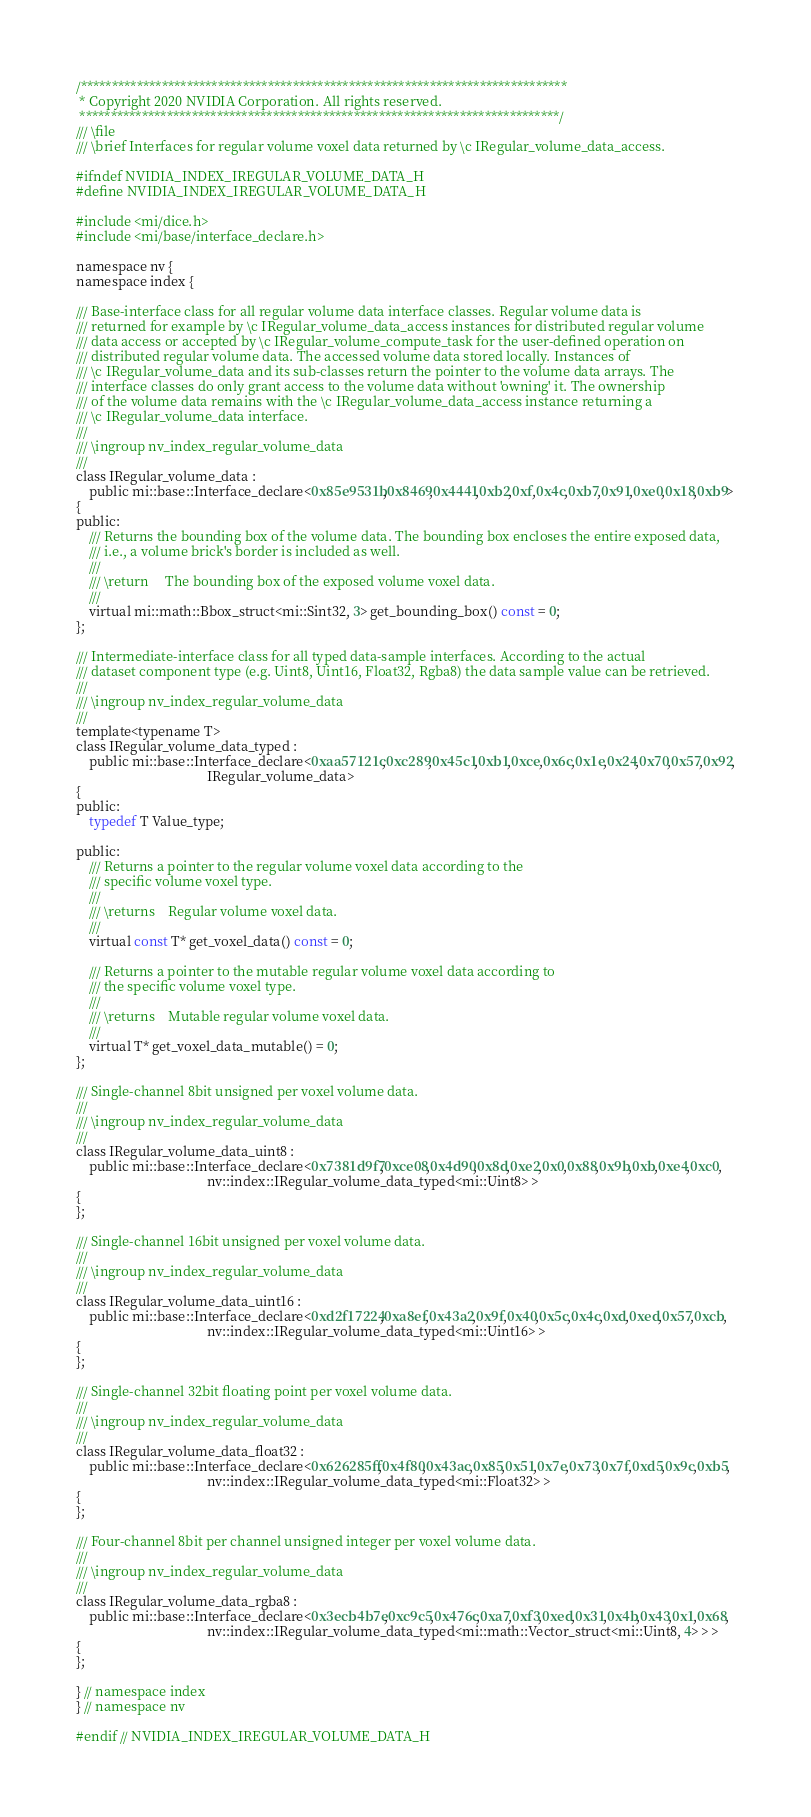Convert code to text. <code><loc_0><loc_0><loc_500><loc_500><_C_>/******************************************************************************
 * Copyright 2020 NVIDIA Corporation. All rights reserved.
 *****************************************************************************/
/// \file
/// \brief Interfaces for regular volume voxel data returned by \c IRegular_volume_data_access.

#ifndef NVIDIA_INDEX_IREGULAR_VOLUME_DATA_H
#define NVIDIA_INDEX_IREGULAR_VOLUME_DATA_H

#include <mi/dice.h>
#include <mi/base/interface_declare.h>

namespace nv {
namespace index {

/// Base-interface class for all regular volume data interface classes. Regular volume data is
/// returned for example by \c IRegular_volume_data_access instances for distributed regular volume
/// data access or accepted by \c IRegular_volume_compute_task for the user-defined operation on
/// distributed regular volume data. The accessed volume data stored locally. Instances of
/// \c IRegular_volume_data and its sub-classes return the pointer to the volume data arrays. The
/// interface classes do only grant access to the volume data without 'owning' it. The ownership
/// of the volume data remains with the \c IRegular_volume_data_access instance returning a
/// \c IRegular_volume_data interface.
///
/// \ingroup nv_index_regular_volume_data
///
class IRegular_volume_data :
    public mi::base::Interface_declare<0x85e9531b,0x8469,0x4441,0xb2,0xf,0x4c,0xb7,0x91,0xe0,0x18,0xb9>
{
public:
    /// Returns the bounding box of the volume data. The bounding box encloses the entire exposed data, 
    /// i.e., a volume brick's border is included as well.
    ///
    /// \return     The bounding box of the exposed volume voxel data.
    ///
    virtual mi::math::Bbox_struct<mi::Sint32, 3> get_bounding_box() const = 0;
};

/// Intermediate-interface class for all typed data-sample interfaces. According to the actual
/// dataset component type (e.g. Uint8, Uint16, Float32, Rgba8) the data sample value can be retrieved.
///
/// \ingroup nv_index_regular_volume_data
///
template<typename T>
class IRegular_volume_data_typed :
    public mi::base::Interface_declare<0xaa57121c,0xc289,0x45c1,0xb1,0xce,0x6c,0x1e,0x24,0x70,0x57,0x92,
                                       IRegular_volume_data>
{
public:
    typedef T Value_type;

public:
    /// Returns a pointer to the regular volume voxel data according to the
    /// specific volume voxel type.
    ///
    /// \returns    Regular volume voxel data.
    ///
    virtual const T* get_voxel_data() const = 0;

    /// Returns a pointer to the mutable regular volume voxel data according to
    /// the specific volume voxel type.
    ///
    /// \returns    Mutable regular volume voxel data.
    ///
    virtual T* get_voxel_data_mutable() = 0;
};

/// Single-channel 8bit unsigned per voxel volume data.
///
/// \ingroup nv_index_regular_volume_data
///
class IRegular_volume_data_uint8 :
    public mi::base::Interface_declare<0x7381d9f7,0xce08,0x4d90,0x8d,0xe2,0x0,0x88,0x9b,0xb,0xe4,0xc0,
                                       nv::index::IRegular_volume_data_typed<mi::Uint8> >
{
};

/// Single-channel 16bit unsigned per voxel volume data.
///
/// \ingroup nv_index_regular_volume_data
///
class IRegular_volume_data_uint16 :
    public mi::base::Interface_declare<0xd2f17224,0xa8ef,0x43a2,0x9f,0x40,0x5c,0x4c,0xd,0xed,0x57,0xcb,
                                       nv::index::IRegular_volume_data_typed<mi::Uint16> >
{
};

/// Single-channel 32bit floating point per voxel volume data.
///
/// \ingroup nv_index_regular_volume_data
///
class IRegular_volume_data_float32 :
    public mi::base::Interface_declare<0x626285ff,0x4f80,0x43ac,0x85,0x51,0x7e,0x73,0x7f,0xd5,0x9c,0xb5,
                                       nv::index::IRegular_volume_data_typed<mi::Float32> >
{
};

/// Four-channel 8bit per channel unsigned integer per voxel volume data.
///
/// \ingroup nv_index_regular_volume_data
///
class IRegular_volume_data_rgba8 :
    public mi::base::Interface_declare<0x3ecb4b7e,0xc9c5,0x476c,0xa7,0xf3,0xed,0x31,0x4b,0x43,0x1,0x68,
                                       nv::index::IRegular_volume_data_typed<mi::math::Vector_struct<mi::Uint8, 4> > >
{
};

} // namespace index
} // namespace nv

#endif // NVIDIA_INDEX_IREGULAR_VOLUME_DATA_H
</code> 